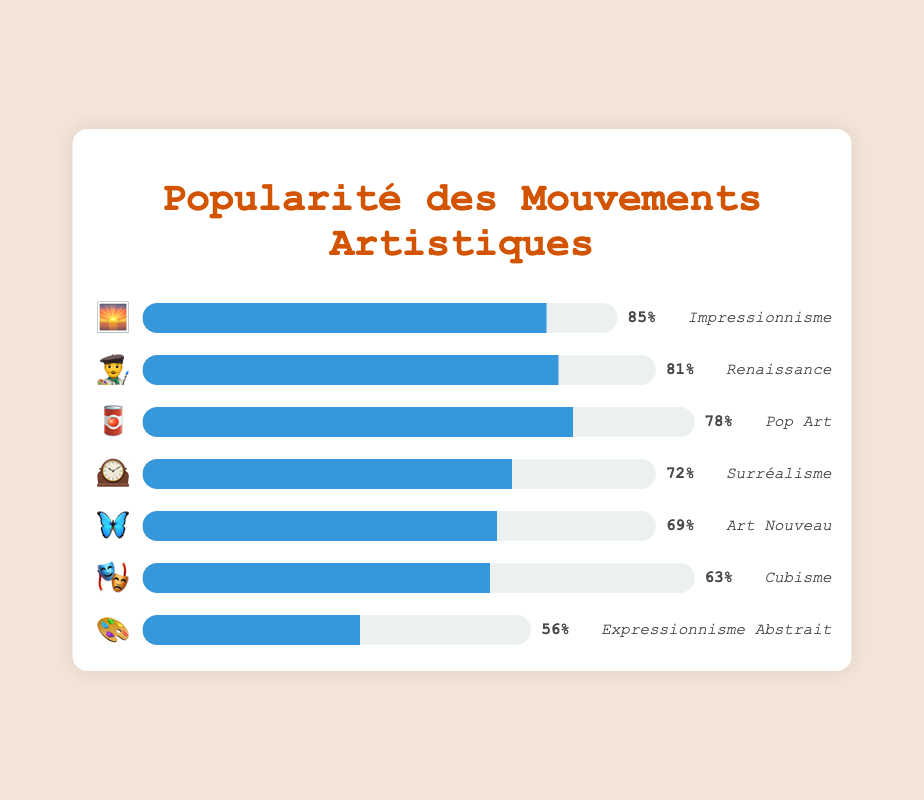Which art movement has the highest popularity? The bar with the emoji 🌅 has the highest percentage at 85%. This represents Impressionism.
Answer: Impressionism What is the popularity difference between Impressionism 🌅 and Surrealism 🕰️? Impressionism has a popularity of 85% and Surrealism has 72%. The difference is 85 - 72 = 13%.
Answer: 13% Which art movements have a popularity greater than 70%? The movements with greater than 70% popularity are Impressionism 🌅 (85%), Renaissance 👨‍🎨 (81%), Pop Art 🥫 (78%), and Surrealism 🕰️ (72%).
Answer: Impressionism, Renaissance, Pop Art, Surrealism What is the average popularity of Cubism 🎭, Art Nouveau 🦋, and Abstract Expressionism 🎨? The popularity values are 63% (Cubism), 69% (Art Nouveau), and 56% (Abstract Expressionism). The sum is 63 + 69 + 56 = 188. The average is 188 / 3 ≈ 62.7%.
Answer: 62.7% Rank the art movements from most popular to least popular. The popularity percentages are: Impressionism 🌅 (85%), Renaissance 👨‍🎨 (81%), Pop Art 🥫 (78%), Surrealism 🕰️ (72%), Art Nouveau 🦋 (69%), Cubism 🎭 (63%), Abstract Expressionism 🎨 (56%). Ranking them: 1. Impressionism, 2. Renaissance, 3. Pop Art, 4. Surrealism, 5. Art Nouveau, 6. Cubism, 7. Abstract Expressionism.
Answer: Impressionism, Renaissance, Pop Art, Surrealism, Art Nouveau, Cubism, Abstract Expressionism Which art movement has a popularity closest to 70%? Surrealism 🕰️ has a popularity of 72% and Art Nouveau 🦋 has a popularity of 69%. The closest value to 70% out of these is 69% (Art Nouveau) as it is only 1% away.
Answer: Art Nouveau How many art movements have a popularity of less than 65%? The movements with less than 65% popularity are Cubism 🎭 (63%) and Abstract Expressionism 🎨 (56%). There are two such movements.
Answer: 2 